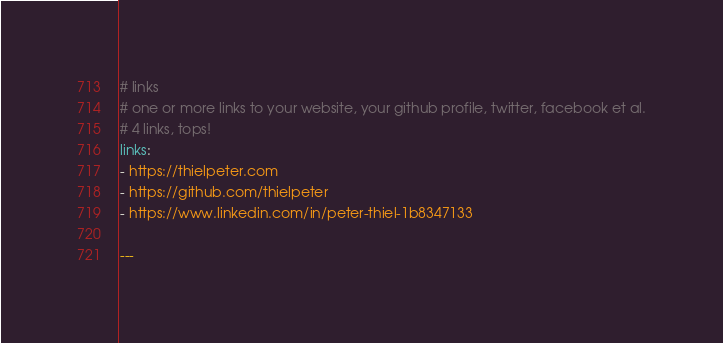Convert code to text. <code><loc_0><loc_0><loc_500><loc_500><_YAML_>
# links
# one or more links to your website, your github profile, twitter, facebook et al.
# 4 links, tops!
links:
- https://thielpeter.com
- https://github.com/thielpeter
- https://www.linkedin.com/in/peter-thiel-1b8347133

---
</code> 